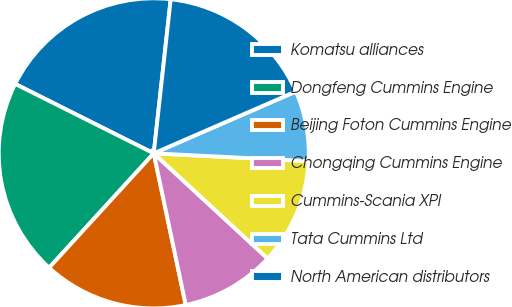Convert chart. <chart><loc_0><loc_0><loc_500><loc_500><pie_chart><fcel>Komatsu alliances<fcel>Dongfeng Cummins Engine<fcel>Beijing Foton Cummins Engine<fcel>Chongqing Cummins Engine<fcel>Cummins-Scania XPI<fcel>Tata Cummins Ltd<fcel>North American distributors<nl><fcel>19.35%<fcel>20.6%<fcel>15.1%<fcel>9.82%<fcel>11.07%<fcel>7.33%<fcel>16.72%<nl></chart> 